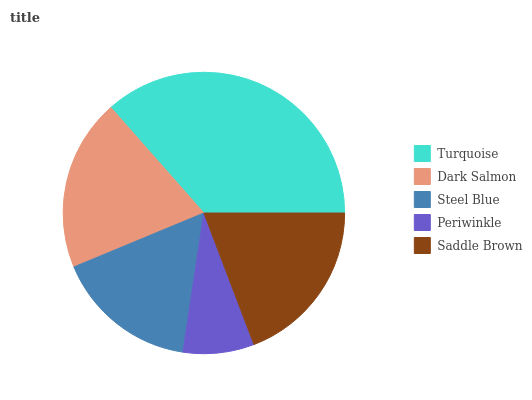Is Periwinkle the minimum?
Answer yes or no. Yes. Is Turquoise the maximum?
Answer yes or no. Yes. Is Dark Salmon the minimum?
Answer yes or no. No. Is Dark Salmon the maximum?
Answer yes or no. No. Is Turquoise greater than Dark Salmon?
Answer yes or no. Yes. Is Dark Salmon less than Turquoise?
Answer yes or no. Yes. Is Dark Salmon greater than Turquoise?
Answer yes or no. No. Is Turquoise less than Dark Salmon?
Answer yes or no. No. Is Saddle Brown the high median?
Answer yes or no. Yes. Is Saddle Brown the low median?
Answer yes or no. Yes. Is Turquoise the high median?
Answer yes or no. No. Is Turquoise the low median?
Answer yes or no. No. 